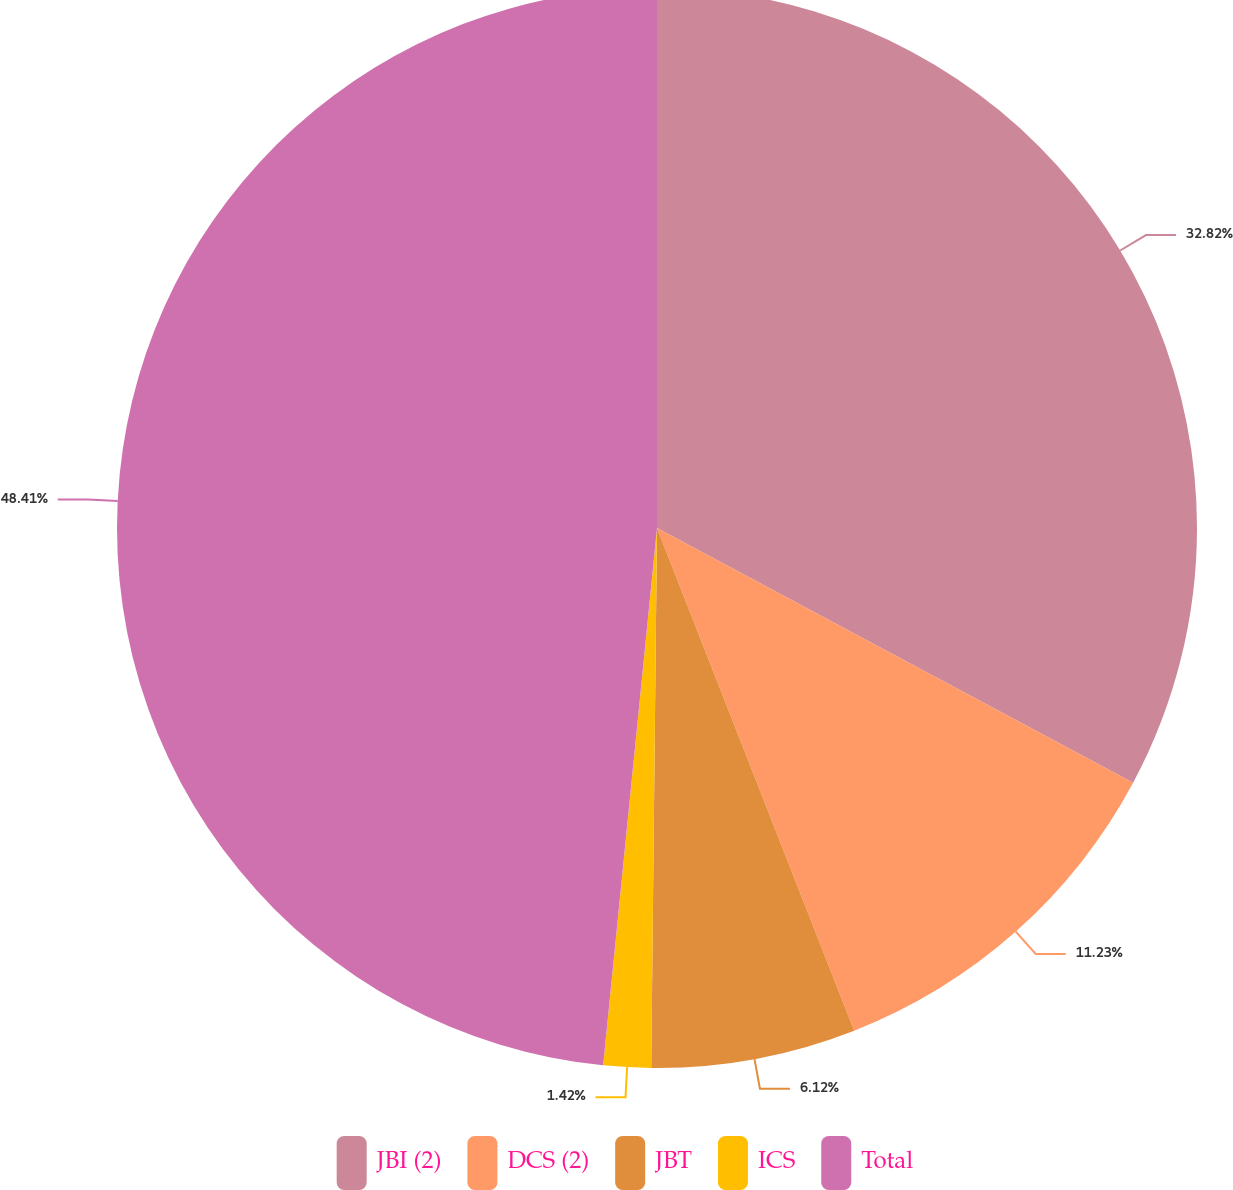Convert chart. <chart><loc_0><loc_0><loc_500><loc_500><pie_chart><fcel>JBI (2)<fcel>DCS (2)<fcel>JBT<fcel>ICS<fcel>Total<nl><fcel>32.82%<fcel>11.23%<fcel>6.12%<fcel>1.42%<fcel>48.41%<nl></chart> 